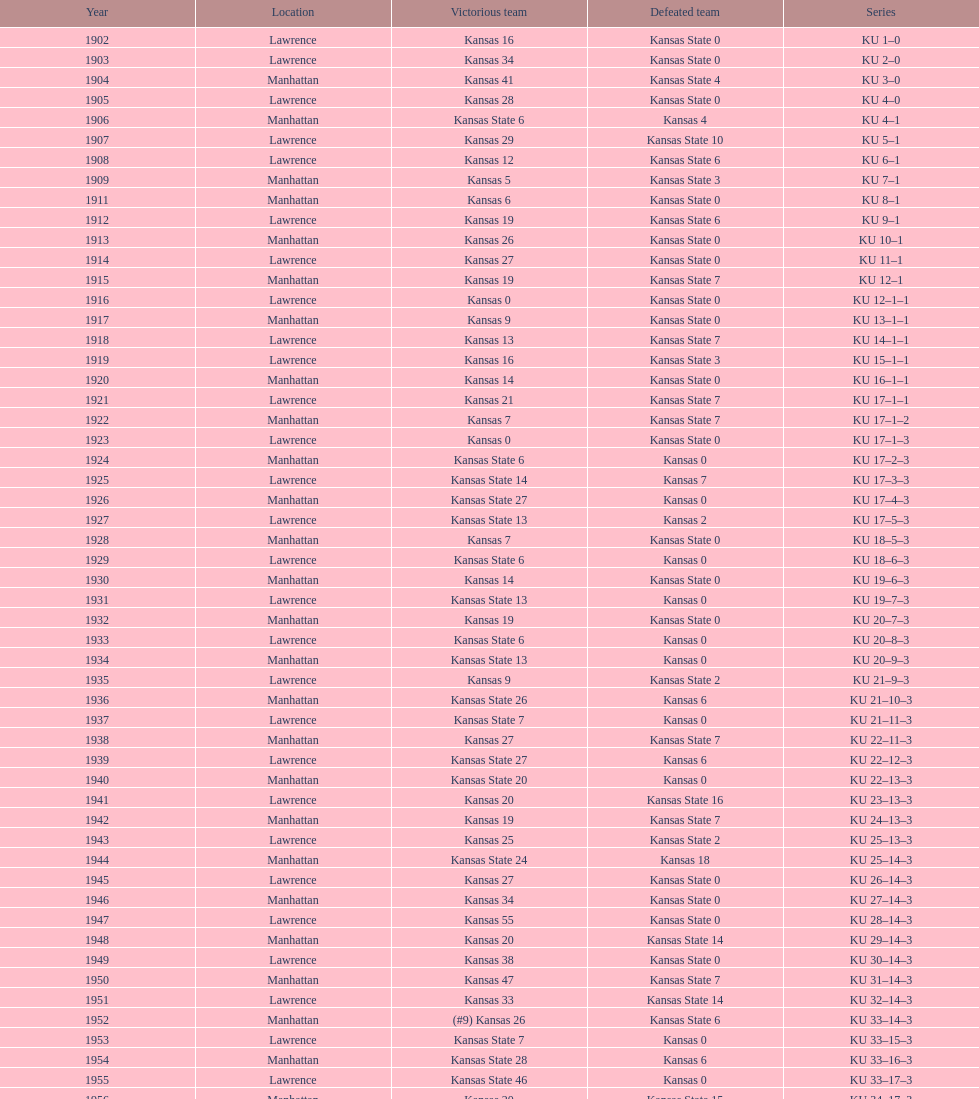What was the number of wins kansas state had in manhattan? 8. 